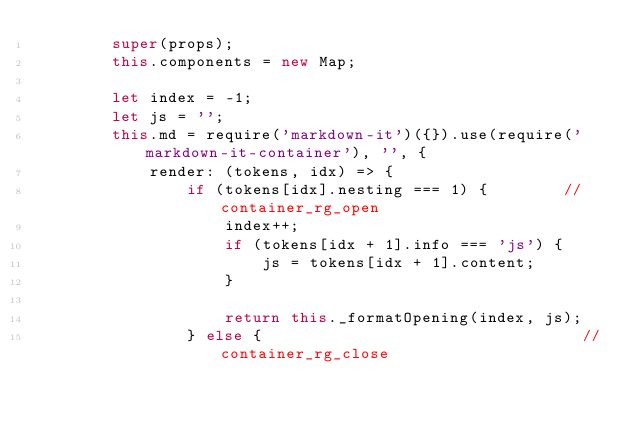<code> <loc_0><loc_0><loc_500><loc_500><_JavaScript_>        super(props);
        this.components = new Map;

        let index = -1;
        let js = '';
        this.md = require('markdown-it')({}).use(require('markdown-it-container'), '', {
            render: (tokens, idx) => {
                if (tokens[idx].nesting === 1) {        //container_rg_open
                    index++;
                    if (tokens[idx + 1].info === 'js') {
                        js = tokens[idx + 1].content;
                    }

                    return this._formatOpening(index, js);
                } else {                                  //container_rg_close</code> 